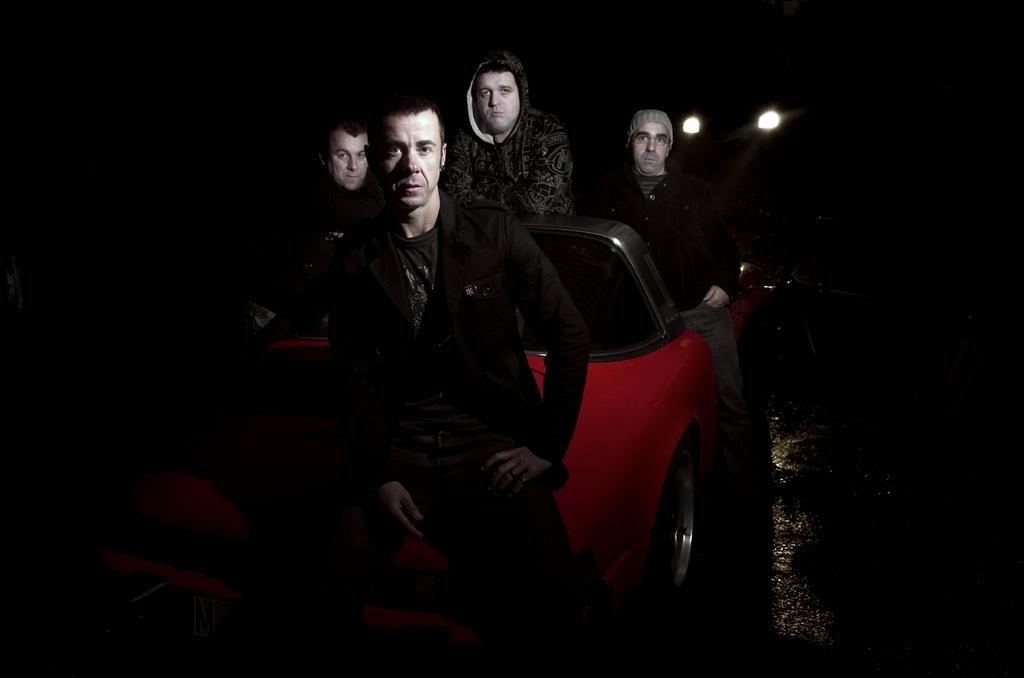How many people are in the image? There is a group of persons in the image. What are the persons doing in the image? The persons are sitting on a red car. What type of books can be seen on the back of the persons in the image? There are no books visible in the image, and the persons' backs are not mentioned in the provided facts. 